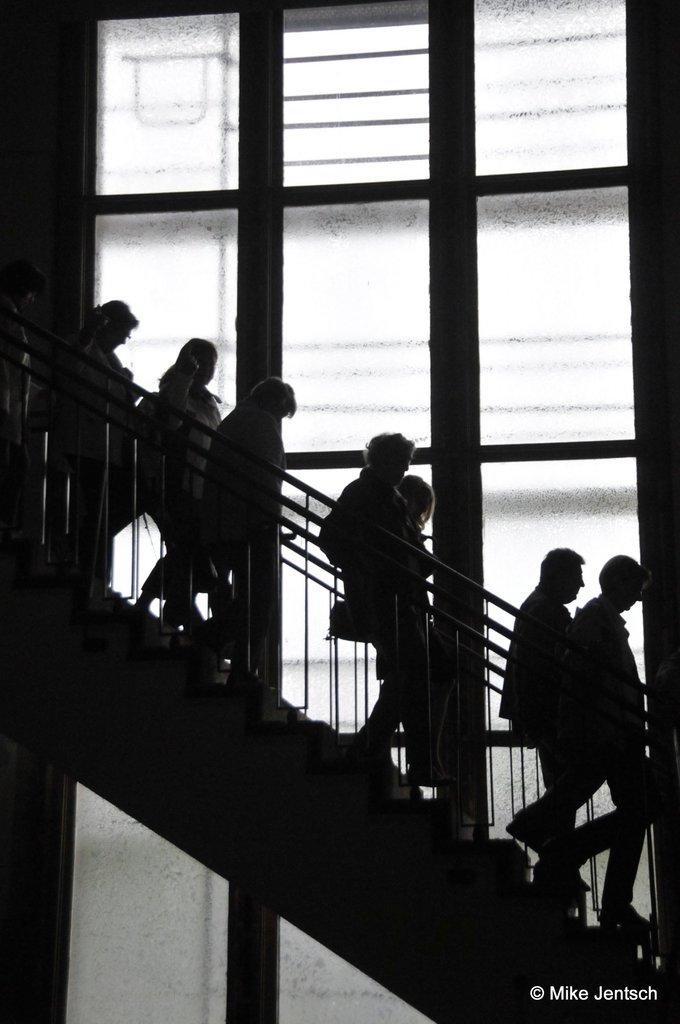What are the people in the image doing? The people in the image are on the stairs. What can be seen near the stairs in the image? There is a railing in the image. What is visible in the background of the image? There is a wall in the background of the image. Can you hear the people on the stairs laughing in the image? There is no sound in the image, so it is not possible to determine if the people are laughing or not. 